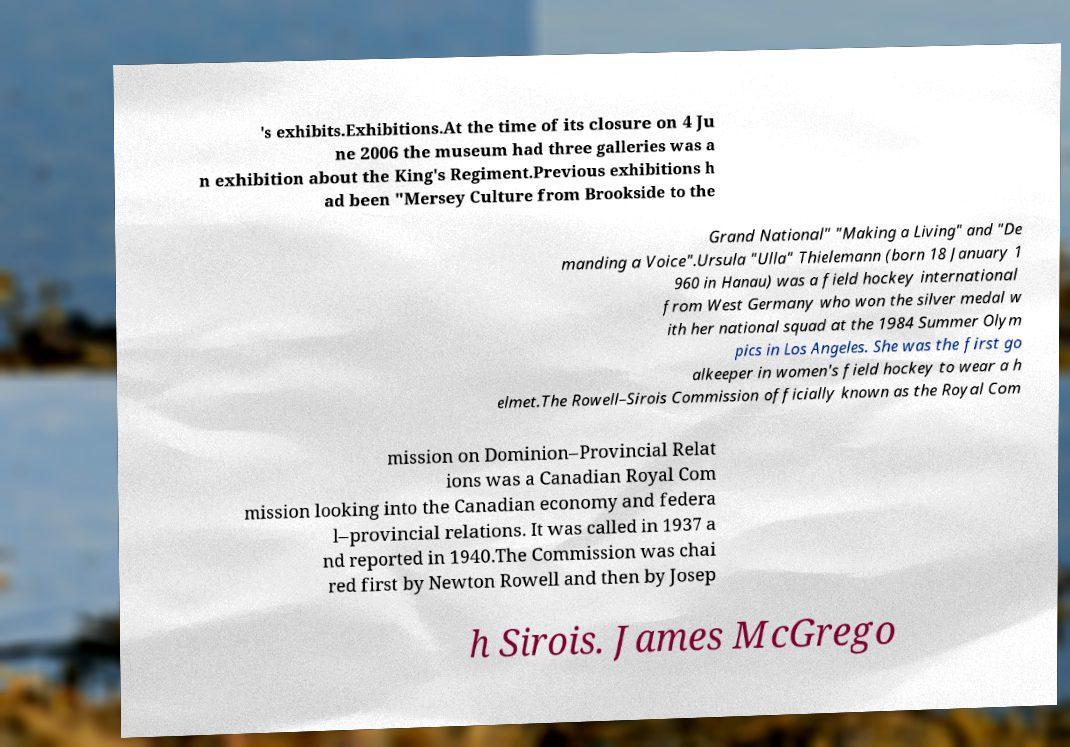Could you assist in decoding the text presented in this image and type it out clearly? 's exhibits.Exhibitions.At the time of its closure on 4 Ju ne 2006 the museum had three galleries was a n exhibition about the King's Regiment.Previous exhibitions h ad been "Mersey Culture from Brookside to the Grand National" "Making a Living" and "De manding a Voice".Ursula "Ulla" Thielemann (born 18 January 1 960 in Hanau) was a field hockey international from West Germany who won the silver medal w ith her national squad at the 1984 Summer Olym pics in Los Angeles. She was the first go alkeeper in women's field hockey to wear a h elmet.The Rowell–Sirois Commission officially known as the Royal Com mission on Dominion–Provincial Relat ions was a Canadian Royal Com mission looking into the Canadian economy and federa l–provincial relations. It was called in 1937 a nd reported in 1940.The Commission was chai red first by Newton Rowell and then by Josep h Sirois. James McGrego 